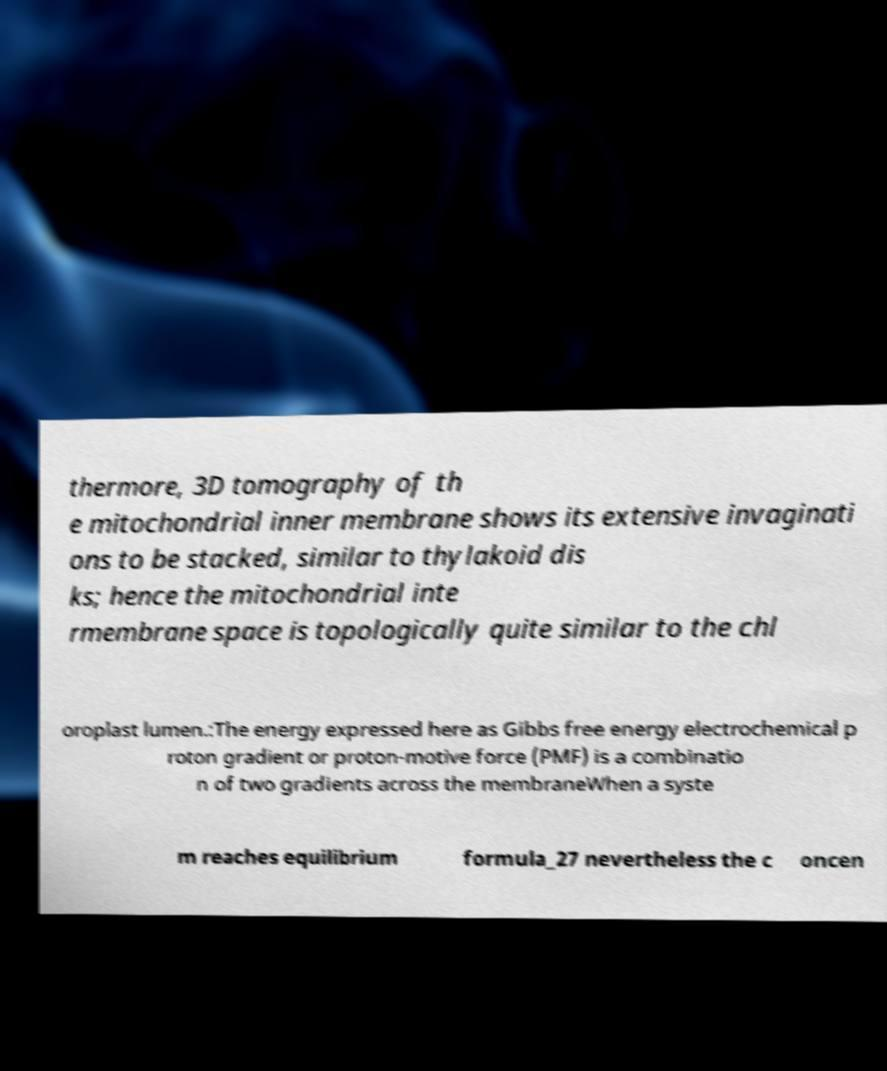Could you assist in decoding the text presented in this image and type it out clearly? thermore, 3D tomography of th e mitochondrial inner membrane shows its extensive invaginati ons to be stacked, similar to thylakoid dis ks; hence the mitochondrial inte rmembrane space is topologically quite similar to the chl oroplast lumen.:The energy expressed here as Gibbs free energy electrochemical p roton gradient or proton-motive force (PMF) is a combinatio n of two gradients across the membraneWhen a syste m reaches equilibrium formula_27 nevertheless the c oncen 